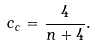Convert formula to latex. <formula><loc_0><loc_0><loc_500><loc_500>c _ { c } = \frac { 4 } { n + 4 } .</formula> 